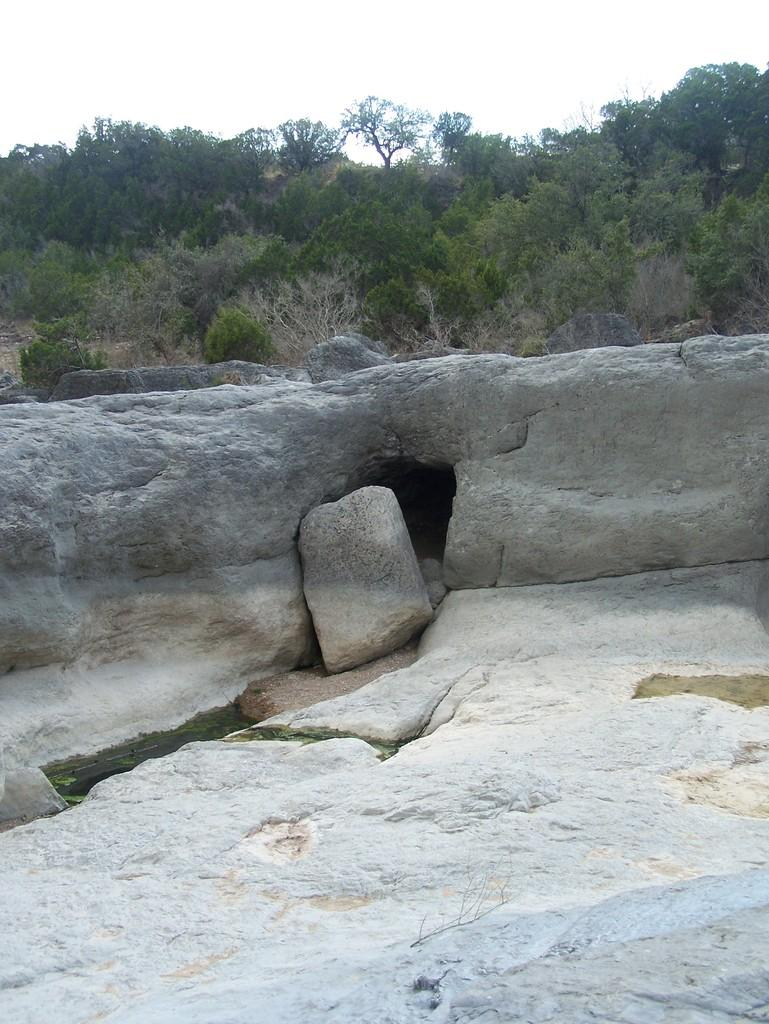What type of natural elements can be seen in the image? There are rocks and trees visible in the image. What is the background of the image? The background of the image includes trees. What is visible at the top of the image? The sky is visible at the top of the image. What can be seen between the rocks on the left side of the image? There is water between the rocks on the left side of the image. How many girls are shaking the tin in the image? There are no girls or tin present in the image. 